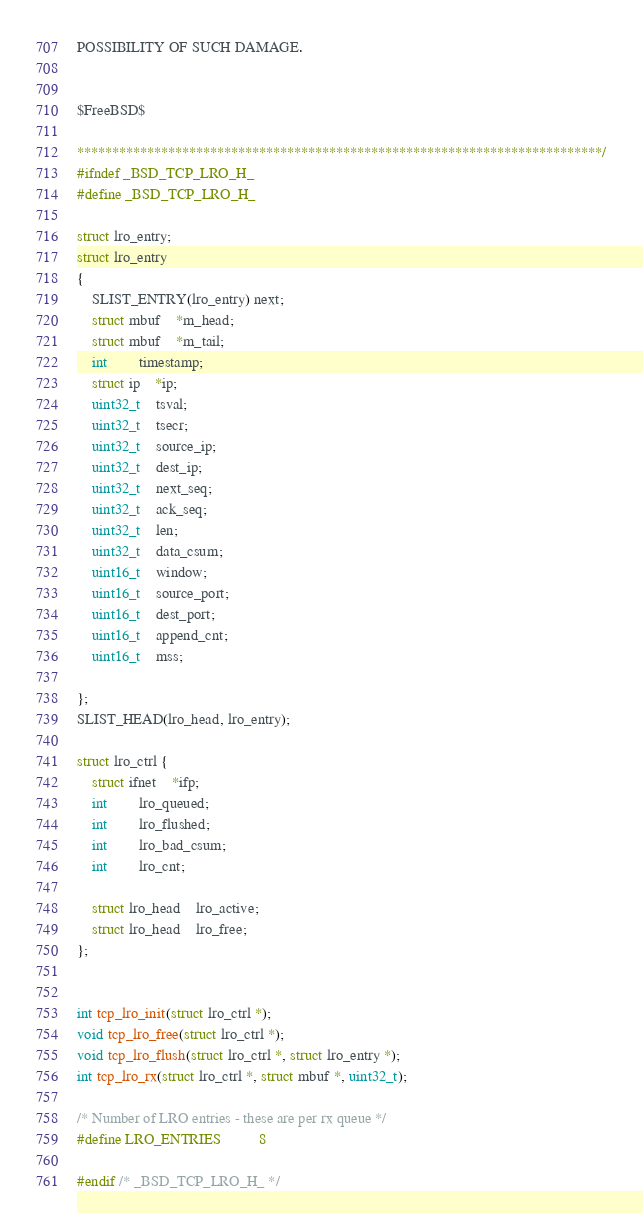<code> <loc_0><loc_0><loc_500><loc_500><_C_>POSSIBILITY OF SUCH DAMAGE.


$FreeBSD$

***************************************************************************/
#ifndef _BSD_TCP_LRO_H_
#define _BSD_TCP_LRO_H_

struct lro_entry;
struct lro_entry
{
	SLIST_ENTRY(lro_entry) next;
	struct mbuf  	*m_head;
	struct mbuf	*m_tail;
	int		timestamp;
	struct ip	*ip;
	uint32_t	tsval;
	uint32_t	tsecr;
	uint32_t	source_ip;
	uint32_t	dest_ip;
	uint32_t	next_seq;
	uint32_t	ack_seq;
	uint32_t	len;
	uint32_t	data_csum;
	uint16_t	window;
	uint16_t	source_port;
	uint16_t	dest_port;
	uint16_t	append_cnt;
	uint16_t	mss;
	
};
SLIST_HEAD(lro_head, lro_entry);

struct lro_ctrl {
	struct ifnet	*ifp;
	int		lro_queued;
	int		lro_flushed;
	int		lro_bad_csum;
	int		lro_cnt;

	struct lro_head	lro_active;
	struct lro_head	lro_free;
};


int tcp_lro_init(struct lro_ctrl *);
void tcp_lro_free(struct lro_ctrl *);
void tcp_lro_flush(struct lro_ctrl *, struct lro_entry *);
int tcp_lro_rx(struct lro_ctrl *, struct mbuf *, uint32_t);

/* Number of LRO entries - these are per rx queue */
#define LRO_ENTRIES			8

#endif /* _BSD_TCP_LRO_H_ */
</code> 